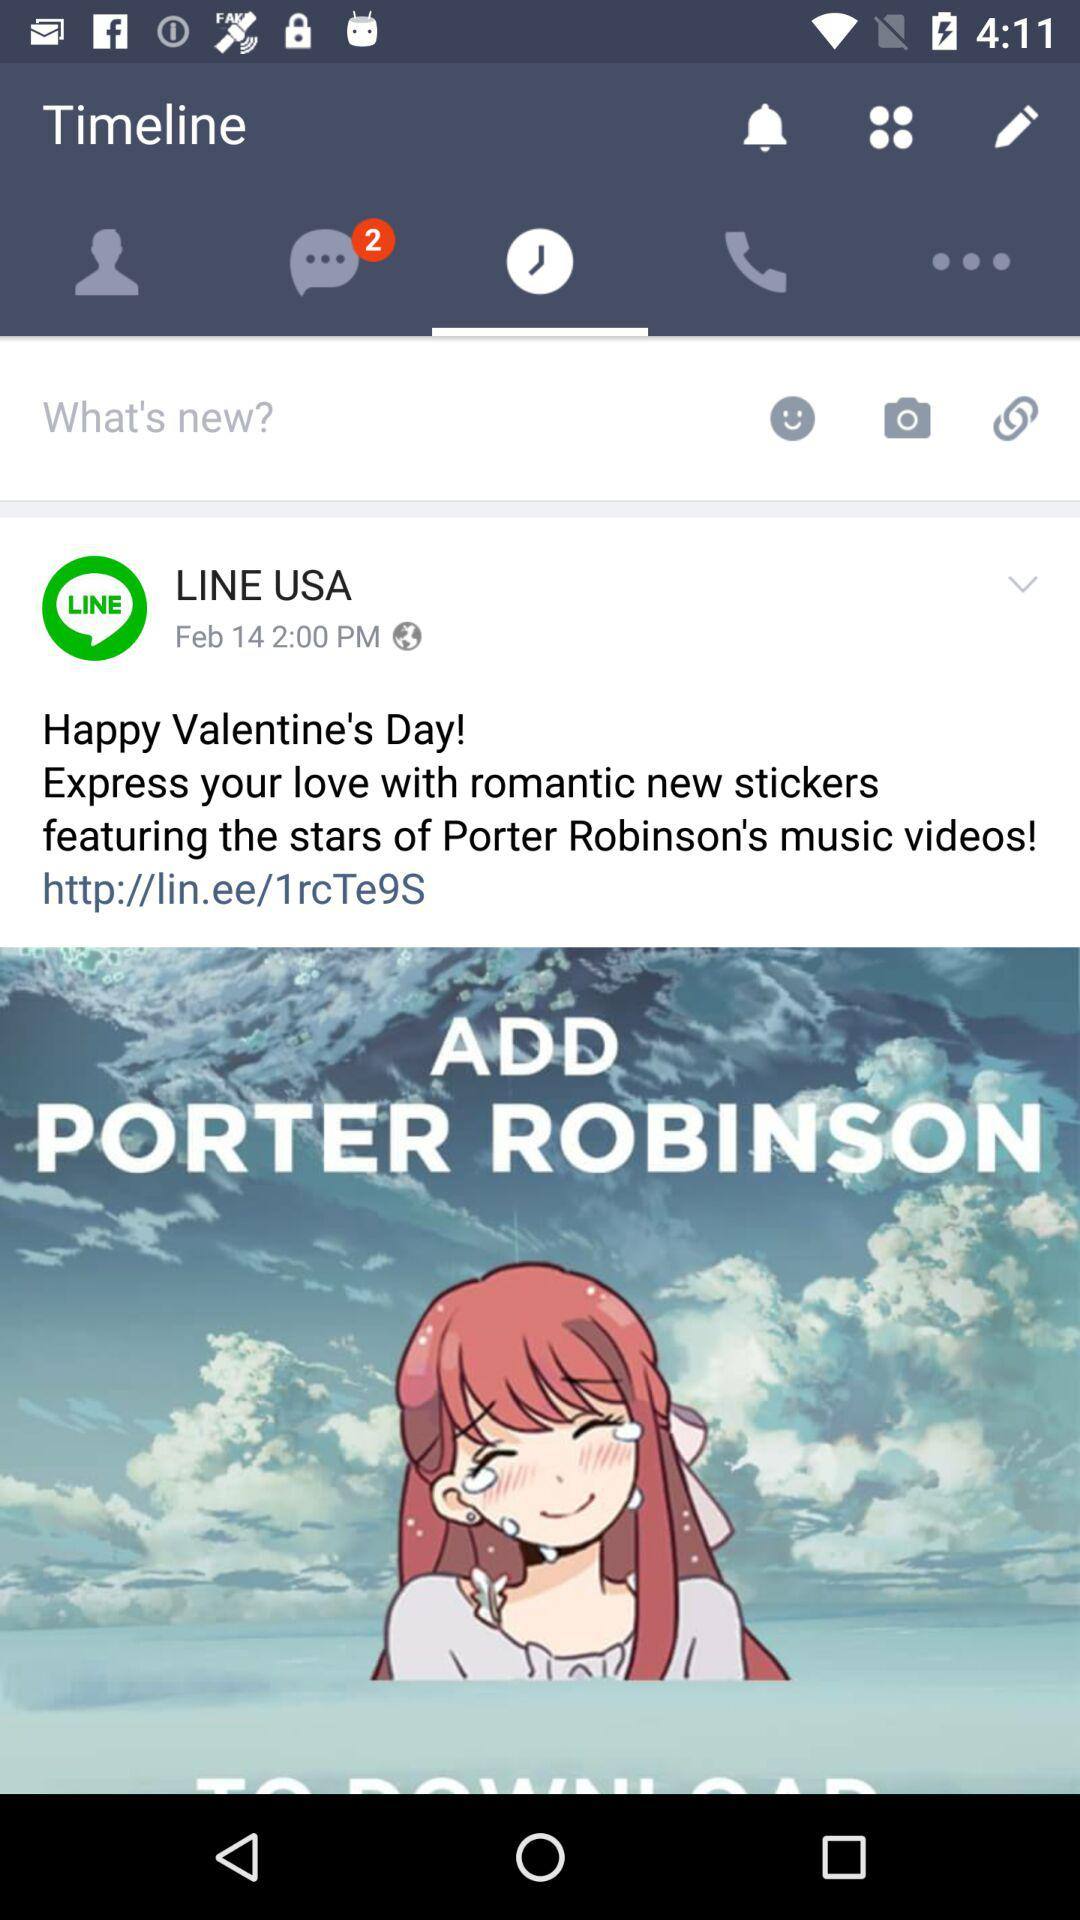What is the publication date of this post? The publication date is February 14. 